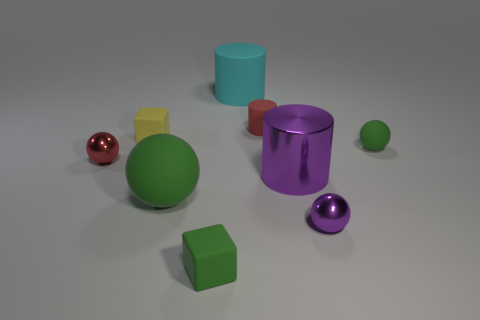Can you tell me the colors of the objects in the image? Certainly! In the image, there is a collection of objects featuring an array of colors: a green sphere, a red sphere, a yellow cube, a teal cylinder, a purple cylindrical ring, a purple sphere, and two green cubes. Each object adds a splash of color to the neutral background. 